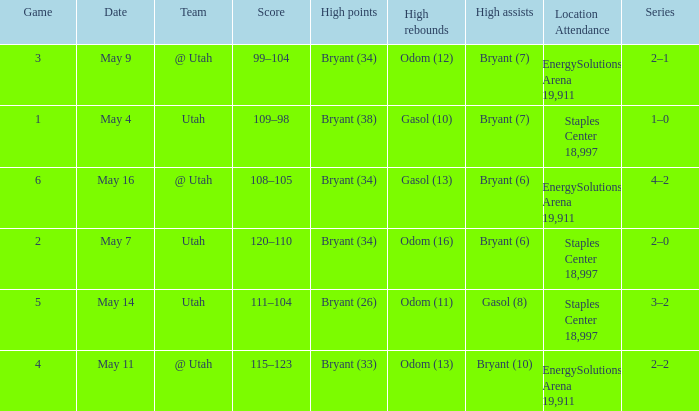What is the Series with a High rebounds with gasol (10)? 1–0. 